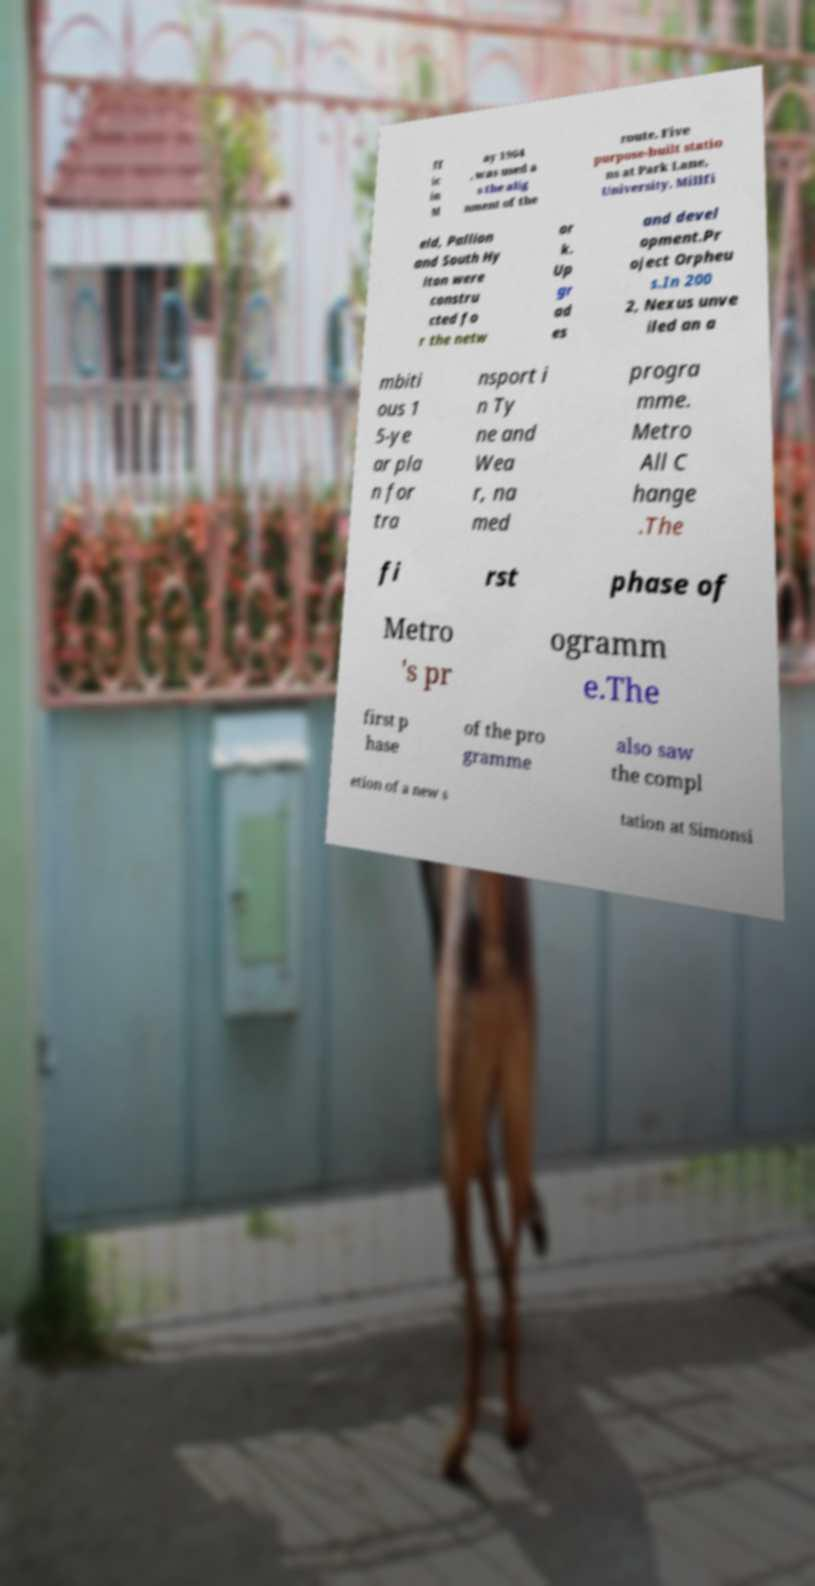Could you extract and type out the text from this image? ff ic in M ay 1964 , was used a s the alig nment of the route. Five purpose-built statio ns at Park Lane, University, Millfi eld, Pallion and South Hy lton were constru cted fo r the netw or k. Up gr ad es and devel opment.Pr oject Orpheu s.In 200 2, Nexus unve iled an a mbiti ous 1 5-ye ar pla n for tra nsport i n Ty ne and Wea r, na med progra mme. Metro All C hange .The fi rst phase of Metro 's pr ogramm e.The first p hase of the pro gramme also saw the compl etion of a new s tation at Simonsi 